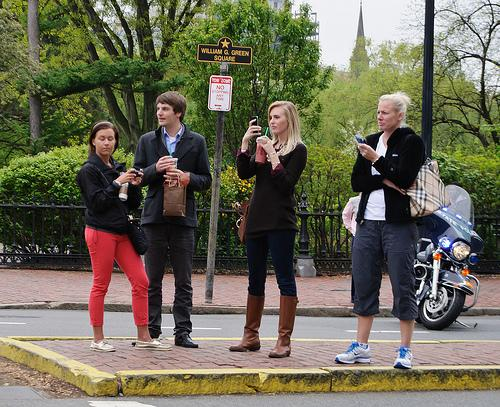Describe the key subject and activity taking place in the image in a concise way. The key subject is a group of pedestrians on a median, engaged in activities like holding cellphones, bags, and beverages. Tell us what stands out the most in this image and describe the situation briefly. A group of people standing in a red brick median catches the eye, with individuals wearing distinctive clothing and doing various tasks. Write a short summary of the main scene and action taking place in the photo. The photo shows pedestrians on a median, wearing different clothes and doing various activities such as using phones and carrying items. Provide a brief description highlighting the key element and action visible within the image. The image highlights pedestrians on a median, taking part in various activities, such as using cellphones, holding bags or drinks. Mention the primary object or person in the image, and describe their most prominent action. Pedestrians standing in the median are the primary focus, engaging in activities like using cellphones and holding beverages. State the key subject and action taking place in this image in a concise manner. Pedestrians on a red brick median engaged in various activities, such as holding phones and carrying bags, comprise the key image subject. Summarize the main focus of the photograph and mention the primary activity occurring. The photograph mainly focuses on pedestrians standing on a red brick median, with actions like using cellphones or holding beverages. Write a succinct description of the primary object or person present in the image and their ongoing action. The primary image subject is a group of pedestrians on a median, engaged in different activities like using cellphones and holding items. Provide a brief overview of the primary focus and activity in this picture. A group of pedestrians is standing on a median with various outfits and accessories, while a motorcycle is parked nearby. Briefly outline the central element and activity displayed in the picture. The central focus is a group of pedestrians on a median, engaged in different activities like using phones, holding bags, or drinks. 